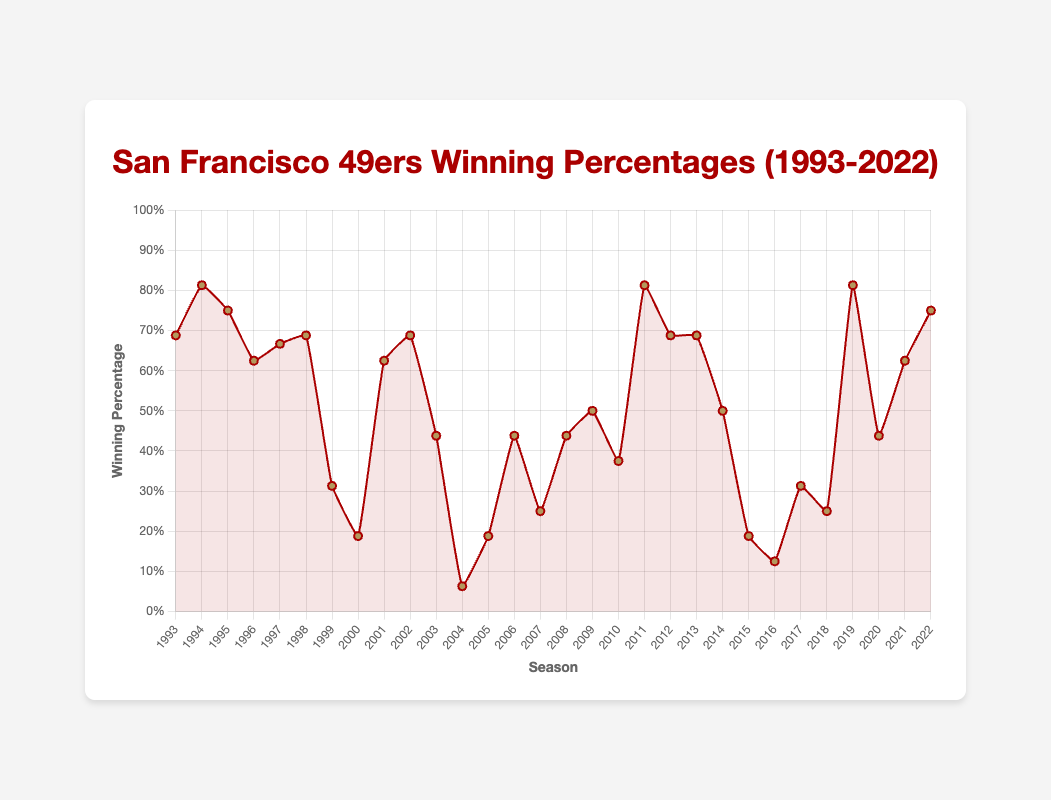Which season(s) had the highest winning percentage? The highest winning percentages are marked by the peak on the line chart. Here, the peaks occur in 1994, 2011, and 2019 all with 81.3%.
Answer: 1994, 2011, 2019 What was the 49ers’ winning percentage during the 2004 season? Locate the year 2004 on the x-axis and find where it intersects with the plotted line to get the percentage. The percentage was 6.3%.
Answer: 6.3% What is the average winning percentage from 1993 to 2022? Sum all the winning percentages and divide by the total number of seasons (30). Calculations: (0.688+0.813+0.750+0.625+0.667+0.688+0.313+0.188+0.625+0.688+0.438+0.063+0.188+0.438+0.25+0.438+0.5+0.375+0.813+0.688+0.688+0.5+0.188+0.125+0.313+0.25+0.813+0.438+0.625+0.75) / 30 = ~0.487
Answer: 0.487 Compare the winning percentages between 2000 and 2005. Which year had the highest increase? Observing the percentage changes, 2004 to 2005 shows the greatest increase. 2004 was 6.3% while 2005 was 18.8%, an increase of 12.5%.
Answer: 2004 to 2005 Which decade shows the most improvement in winning percentages? Compare the winning percentages of each decade. From 2000-2009, the percentages fluctuated a lot but notably increased from the low point in 2004 (6.3%) to 2011 (81.3%).
Answer: 2000-2009 What is the difference in winning percentage between the highest and lowest seasons? The highest percentage is 81.3% and the lowest is 6.3%. The difference is 81.3% - 6.3% = 75%.
Answer: 75% How many seasons did the 49ers have a winning percentage below 50%? Count the number of seasons where the percentage is below 0.500. By examining, there are 14 such seasons.
Answer: 14 Which season had the steepest decline from the previous year? Look for the steepest downward slope between two consecutive seasons. The steepest decline is between 1998 (68.8%) and 1999 (31.3%), a drop of 37.5%.
Answer: 1998 to 1999 How often did the winning percentage stay the same from one season to the next? Check for any consecutive years where the percentages are identical. There are no such seasons where the winning percentages were exactly identical from one year to the next.
Answer: 0 